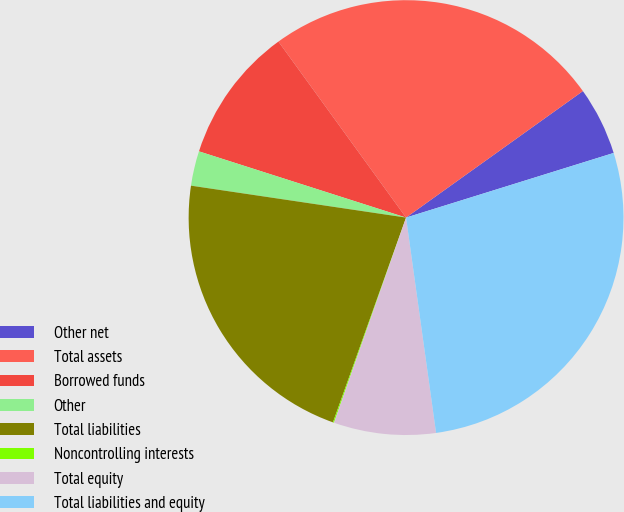Convert chart to OTSL. <chart><loc_0><loc_0><loc_500><loc_500><pie_chart><fcel>Other net<fcel>Total assets<fcel>Borrowed funds<fcel>Other<fcel>Total liabilities<fcel>Noncontrolling interests<fcel>Total equity<fcel>Total liabilities and equity<nl><fcel>5.08%<fcel>25.1%<fcel>10.09%<fcel>2.58%<fcel>21.89%<fcel>0.08%<fcel>7.58%<fcel>27.6%<nl></chart> 